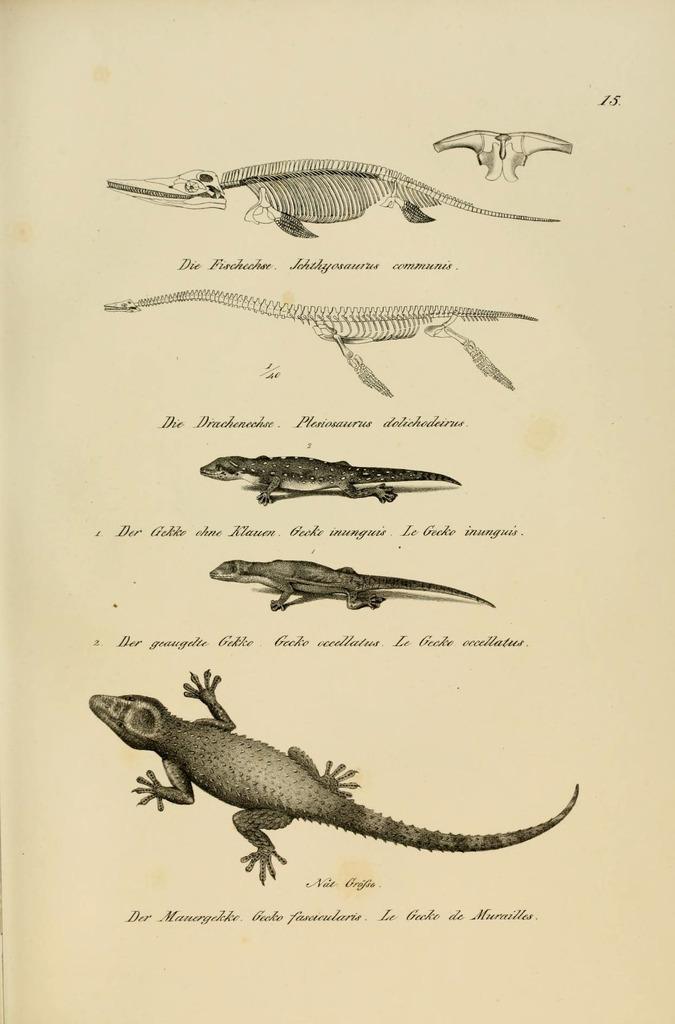Please provide a concise description of this image. In this image, I can see a paper with the pictures of the skeletons and reptiles. There are letters written on the paper. 